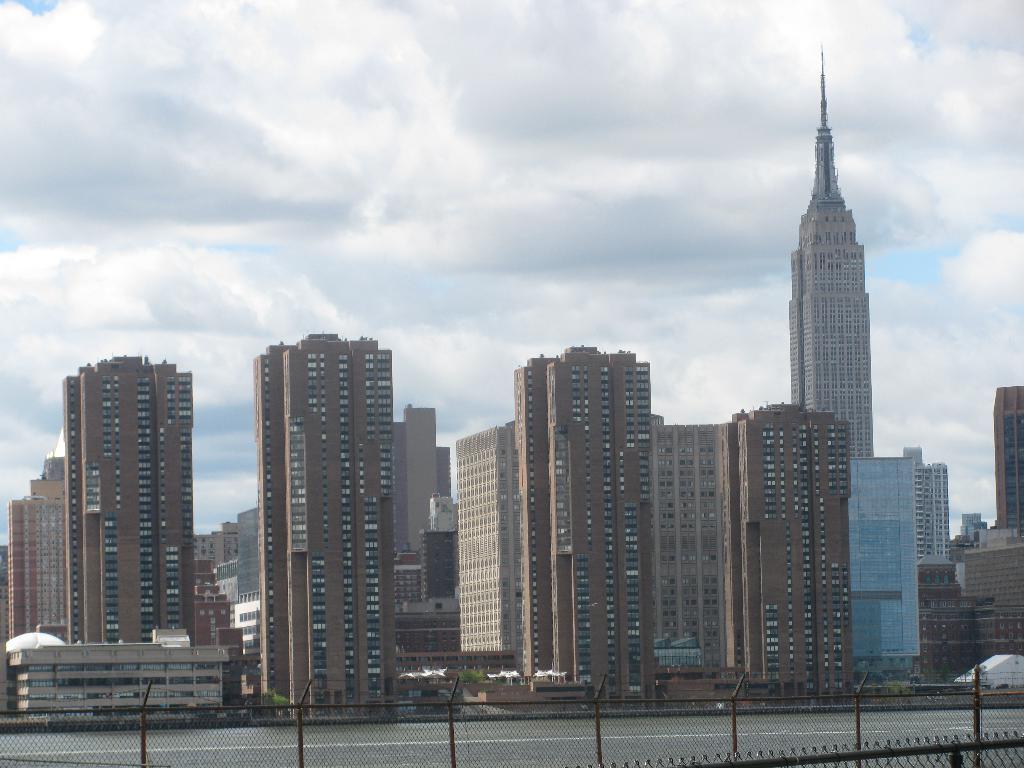Describe this image in one or two sentences. In this image we can see some buildings, a fence and a road. On the backside we can see the sky which looks cloudy. 